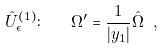Convert formula to latex. <formula><loc_0><loc_0><loc_500><loc_500>\hat { U } ^ { ( 1 ) } _ { \epsilon } \colon \quad \Omega ^ { \prime } = \frac { 1 } { | y _ { 1 } | } \hat { \Omega } \ ,</formula> 